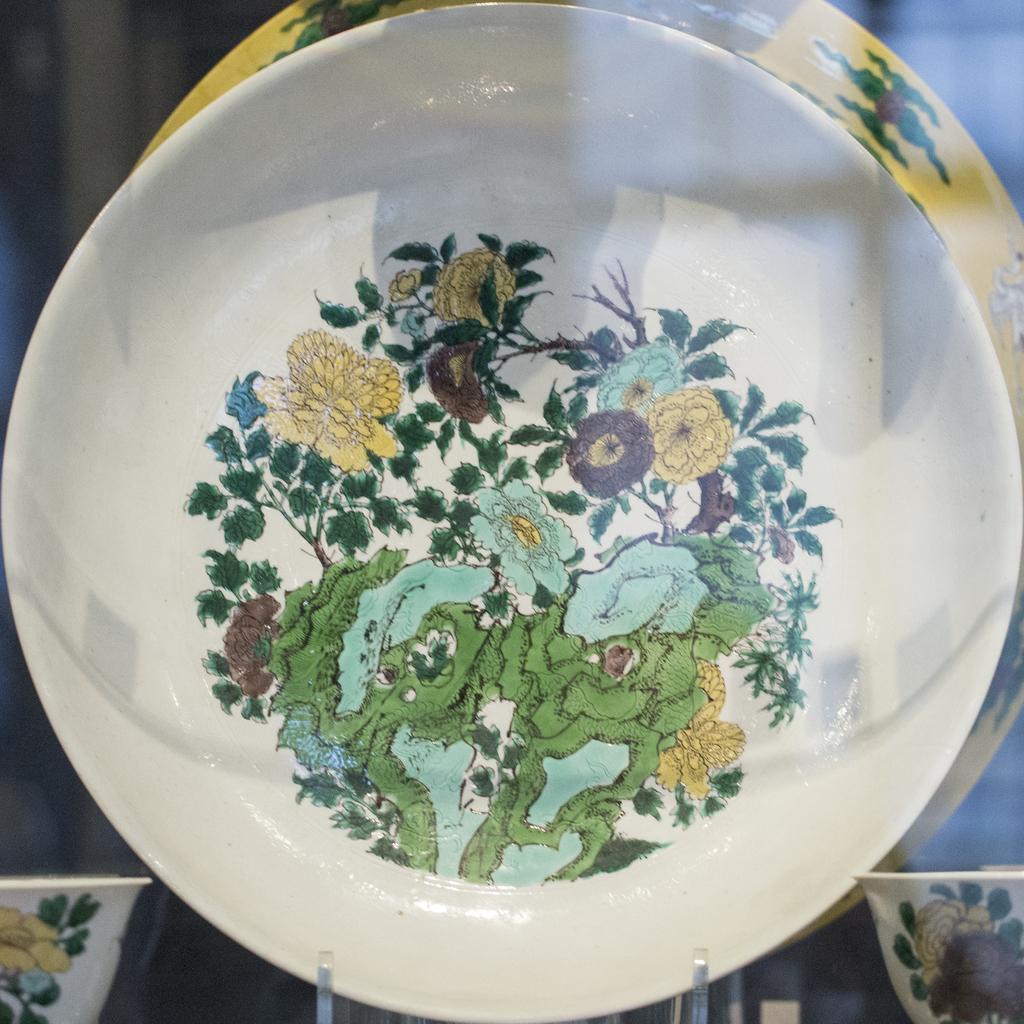In one or two sentences, can you explain what this image depicts? This is a plate, there are paintings of plants in it. 